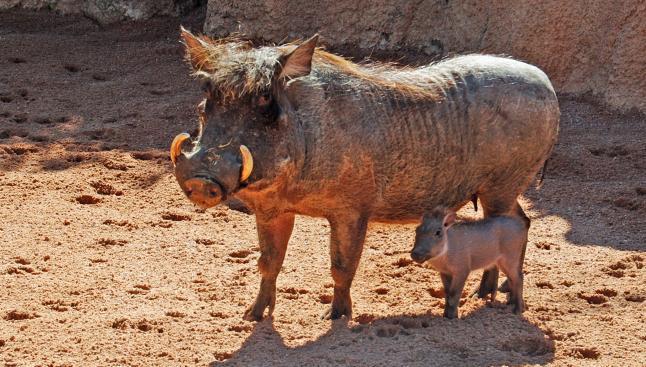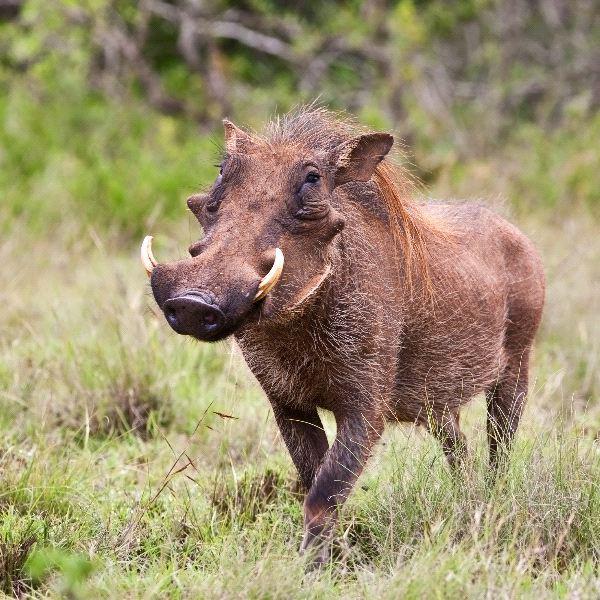The first image is the image on the left, the second image is the image on the right. Given the left and right images, does the statement "The hog on the right has it's mouth on the ground." hold true? Answer yes or no. No. 